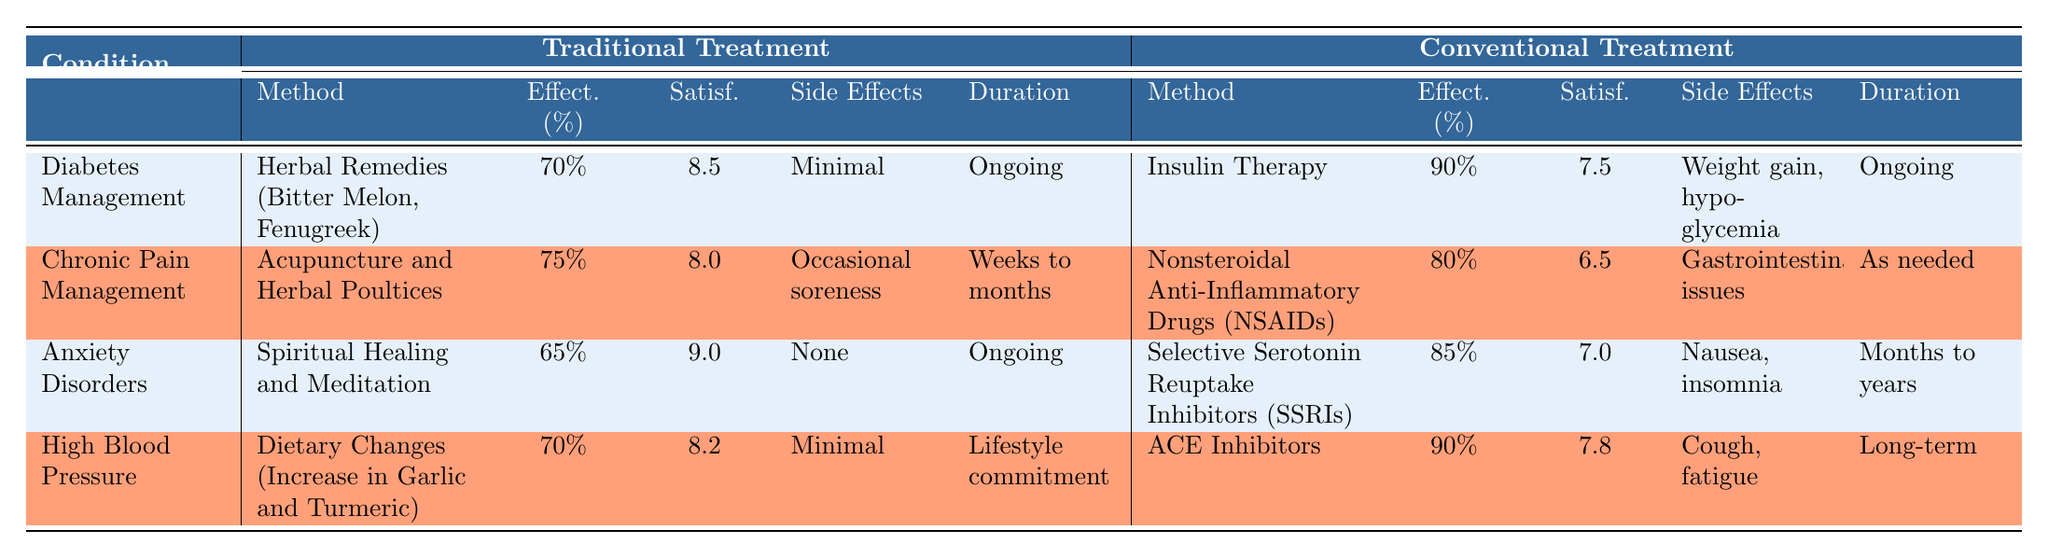What is the effectiveness percentage of traditional treatment for diabetes management? The table states that the effectiveness percentage for traditional treatment in diabetes management is 70%.
Answer: 70% What method is used in traditional treatment for chronic pain management? According to the table, the traditional treatment method for chronic pain management is Acupuncture and Herbal Poultices.
Answer: Acupuncture and Herbal Poultices Do traditional treatments for anxiety disorders have side effects? The table indicates that the traditional treatment for anxiety disorders, which is Spiritual Healing and Meditation, has no side effects listed.
Answer: No What is the patient satisfaction score for conventional treatment of diabetes management? The table shows that the patient satisfaction score for conventional treatment (Insulin Therapy) in diabetes management is 7.5.
Answer: 7.5 Which treatment method for high blood pressure results in a higher effectiveness percentage, traditional or conventional? The effectiveness percentage for traditional treatment (70%) is lower than that of conventional treatment (90%) for high blood pressure. This shows that conventional treatment is more effective.
Answer: Conventional treatment What is the average patient satisfaction score of traditional treatments across all conditions? Adding the patient satisfaction scores from traditional treatments gives us 8.5 + 8.0 + 9.0 + 8.2 = 33.7. There are 4 conditions, so the average is 33.7 / 4 = 8.425.
Answer: 8.425 Is there any condition for which the effectiveness percentage is the same for both traditional and conventional treatments? The table shows that for none of the conditions is the effectiveness percentage the same; traditional treatments are all lower than conventional ones.
Answer: No What is the difference in effectiveness percentage between the traditional and conventional treatments for anxiety disorders? The effectiveness percentage for traditional treatment (65%) compared to conventional treatment (85%) shows a difference of 85% - 65% = 20%.
Answer: 20% Which traditional treatment method has the highest patient satisfaction score? Among the traditional treatment methods, Spiritual Healing and Meditation have the highest patient satisfaction score of 9.0 for anxiety disorders.
Answer: Spiritual Healing and Meditation 